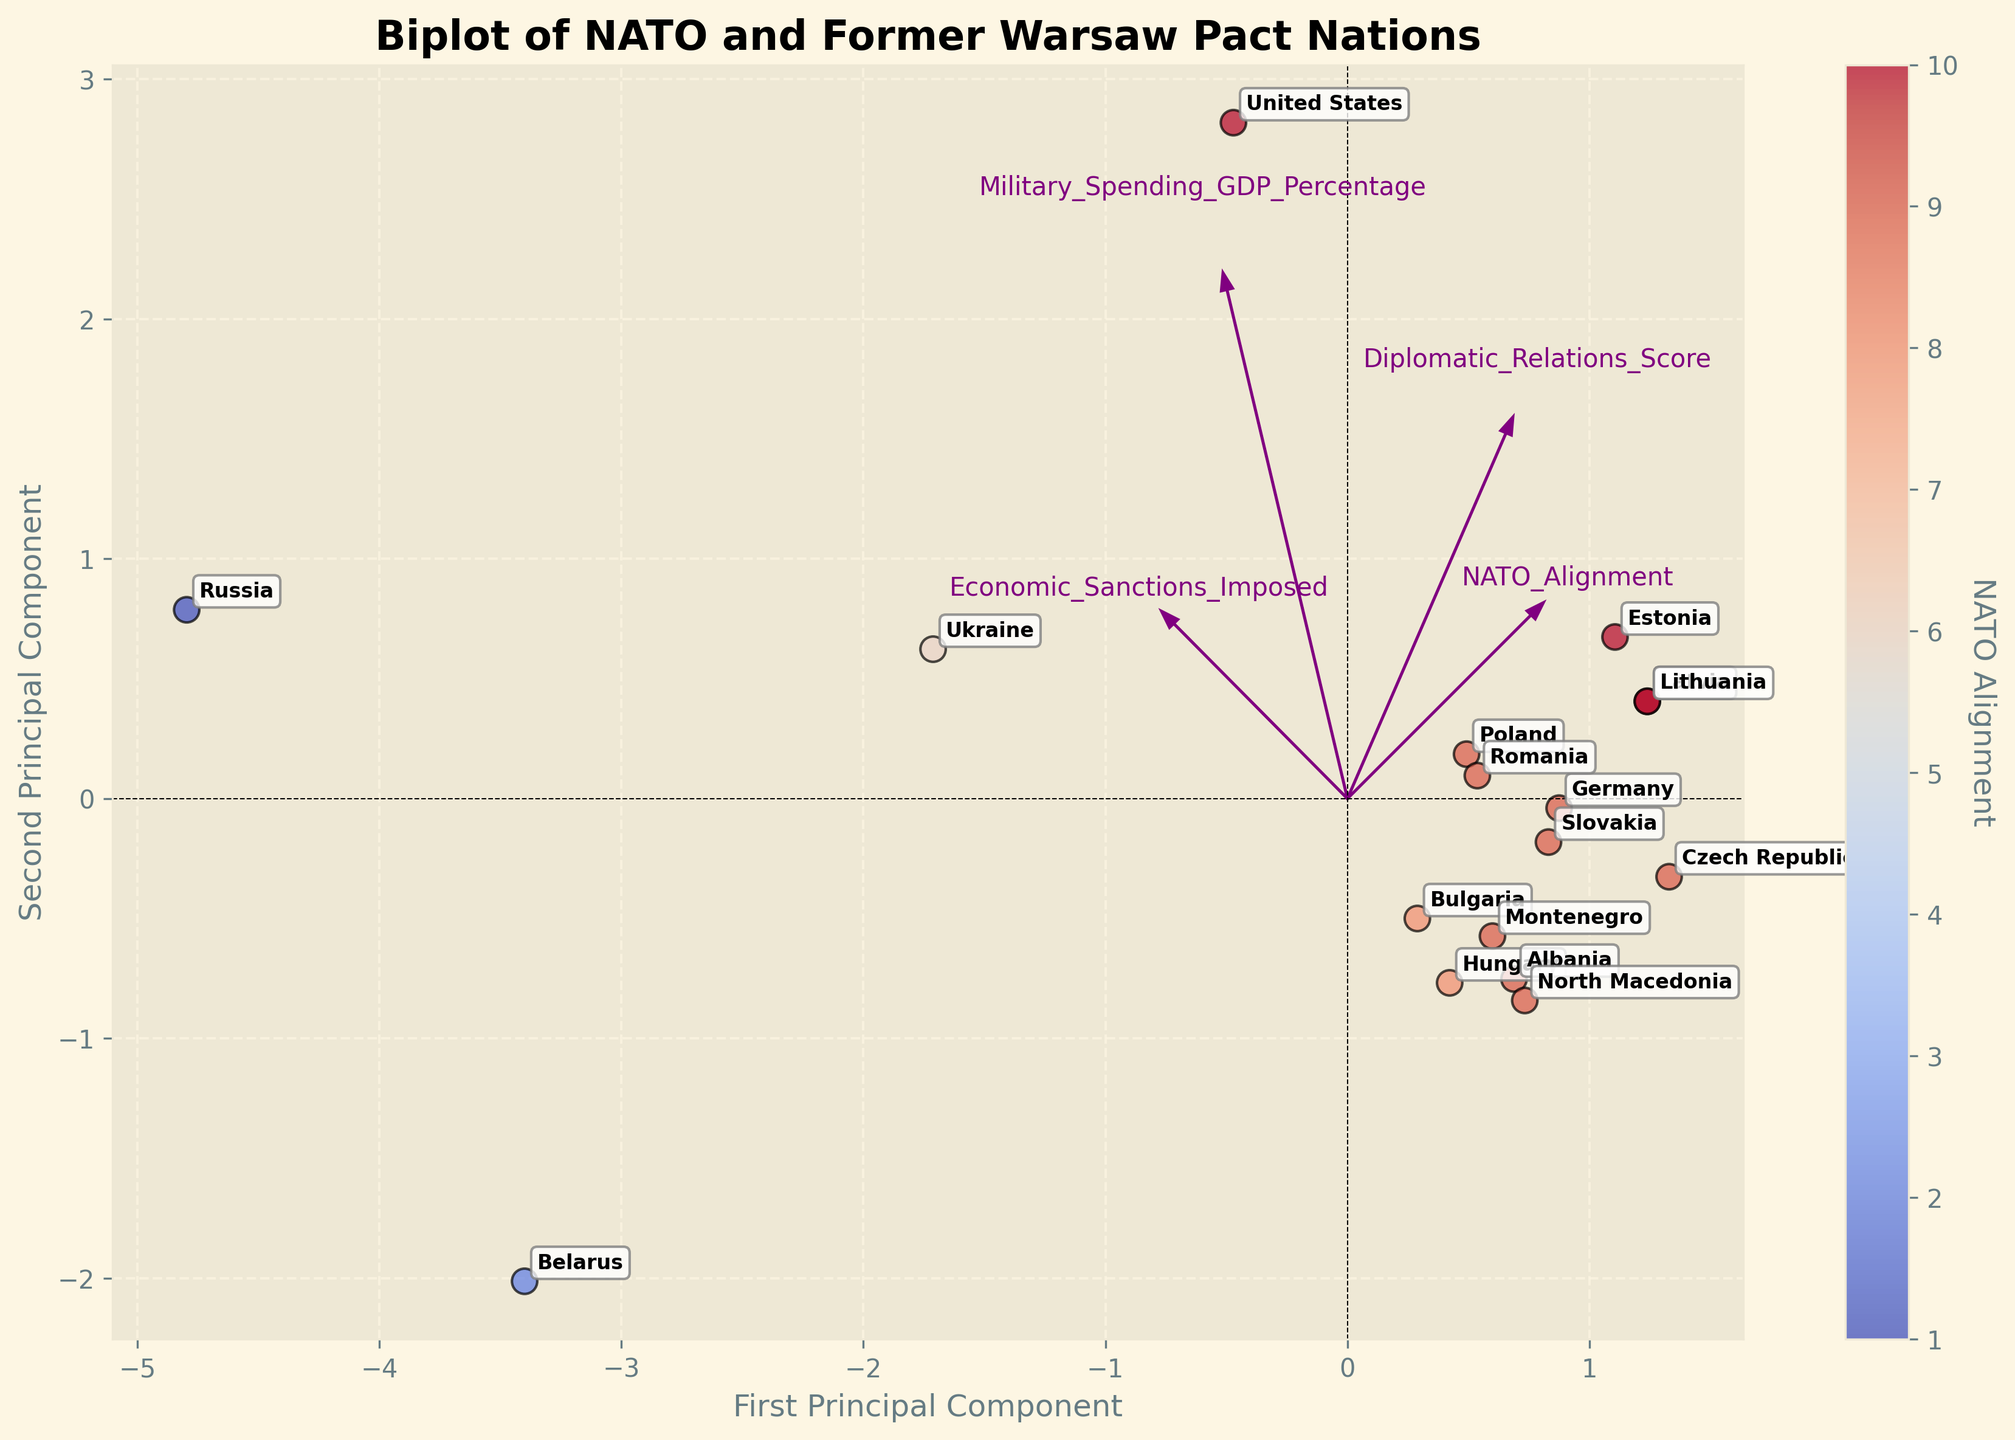What is the title of the plot? The title of the plot is usually found at the top of the figure. In this case, it is clearly shown in bold and large font.
Answer: Biplot of NATO and Former Warsaw Pact Nations How many countries' data points are represented in the plot? To find this, count the number of unique labels (country names) annotated on the scatter plot.
Answer: 17 Which country is the furthest to the right on the first principal component? Identify the country label that is positioned at the far-right end of the x-axis of the plot.
Answer: Ukraine Which NATO-aligned country has the highest military spending as a percentage of GDP? Look at the color scheme (indicating NATO alignment) and identify the label positioned furthest in the direction of the 'Military_Spending_GDP_Percentage' feature arrow.
Answer: United States What is the alignment of Montenegro based on NATO Alignment? Locate Montenegro on the scatter plot and check its color which represents the NATO Alignment.
Answer: 9 Which dimension is more aligned with the 'Economic_Sanctions_Imposed' arrow vector, the first or the second principal component? Examine the direction of the 'Economic_Sanctions_Imposed' arrow relative to the axes.
Answer: First principal component Compare the Diplomatic Relations Scores of Germany and Belarus. Which country has a higher score? Locate Germany and Belarus on the plot and check their positions relative to the 'Diplomatic_Relations_Score' feature arrow.
Answer: Germany Which country is positioned at the bottom left of the plot? Examine the lower-left quadrant of the plot and identify the country label there.
Answer: Belarus How do the military spending percentages of the United States and Russia compare based on their relative positions to the 'Military_Spending_GDP_Percentage' arrow? Find the positions of the United States and Russia concerning the 'Military_Spending_GDP_Percentage' vector. The one further along the arrow's direction spends more.
Answer: Russia What do the vectors (arrows) represent in the figure? In a biplot, the vectors indicate the direction and strength of each feature's contribution to the principal components.
Answer: Directions and strength of features 